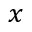<formula> <loc_0><loc_0><loc_500><loc_500>x</formula> 